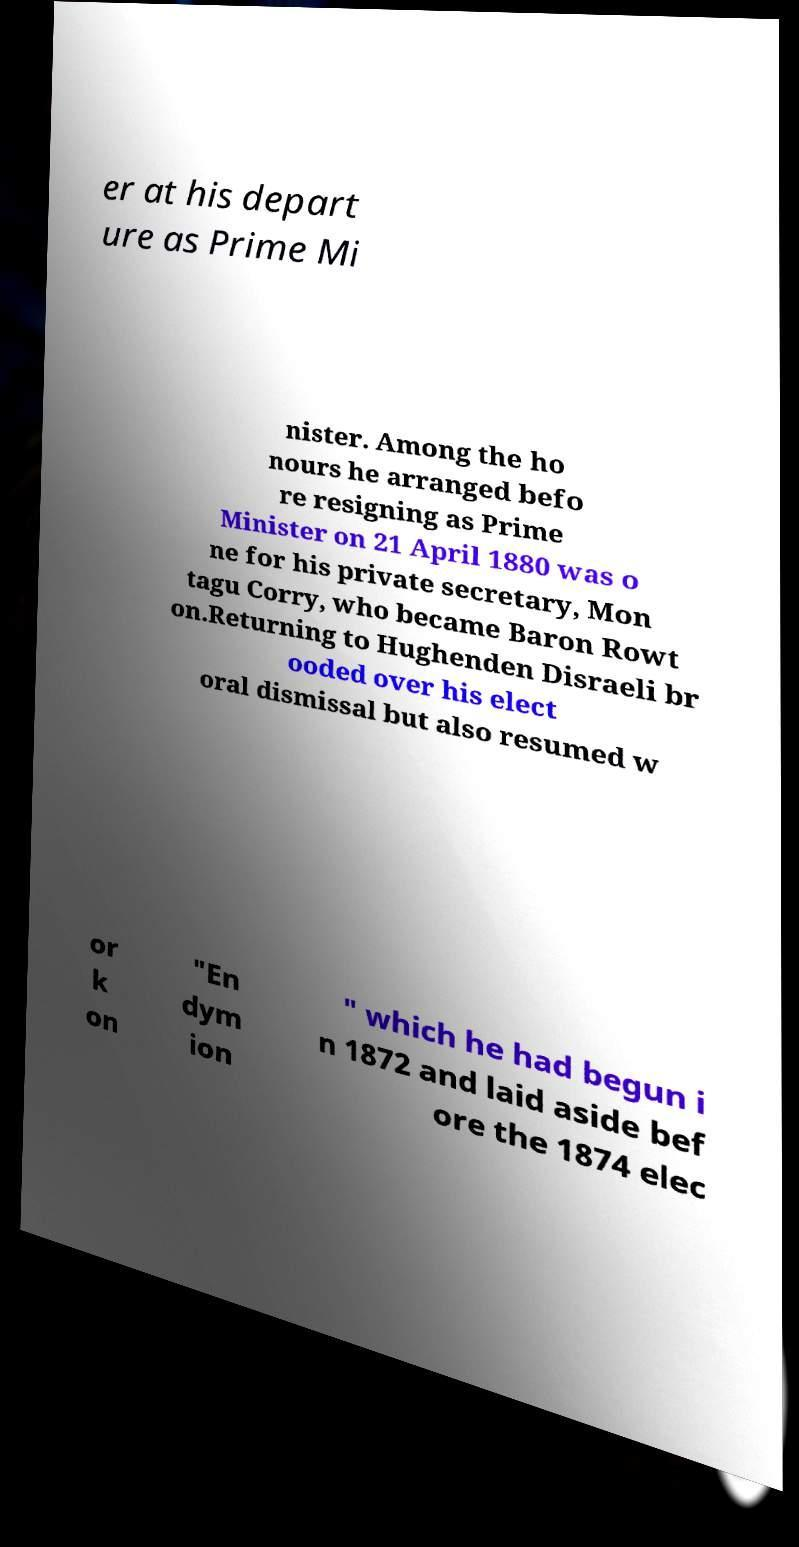For documentation purposes, I need the text within this image transcribed. Could you provide that? er at his depart ure as Prime Mi nister. Among the ho nours he arranged befo re resigning as Prime Minister on 21 April 1880 was o ne for his private secretary, Mon tagu Corry, who became Baron Rowt on.Returning to Hughenden Disraeli br ooded over his elect oral dismissal but also resumed w or k on "En dym ion " which he had begun i n 1872 and laid aside bef ore the 1874 elec 